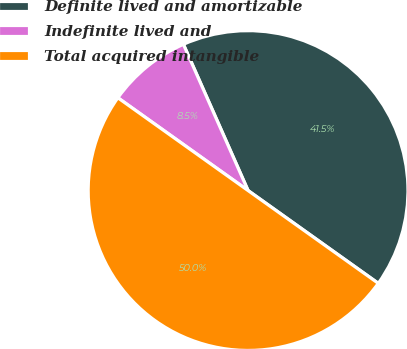Convert chart. <chart><loc_0><loc_0><loc_500><loc_500><pie_chart><fcel>Definite lived and amortizable<fcel>Indefinite lived and<fcel>Total acquired intangible<nl><fcel>41.48%<fcel>8.52%<fcel>50.0%<nl></chart> 